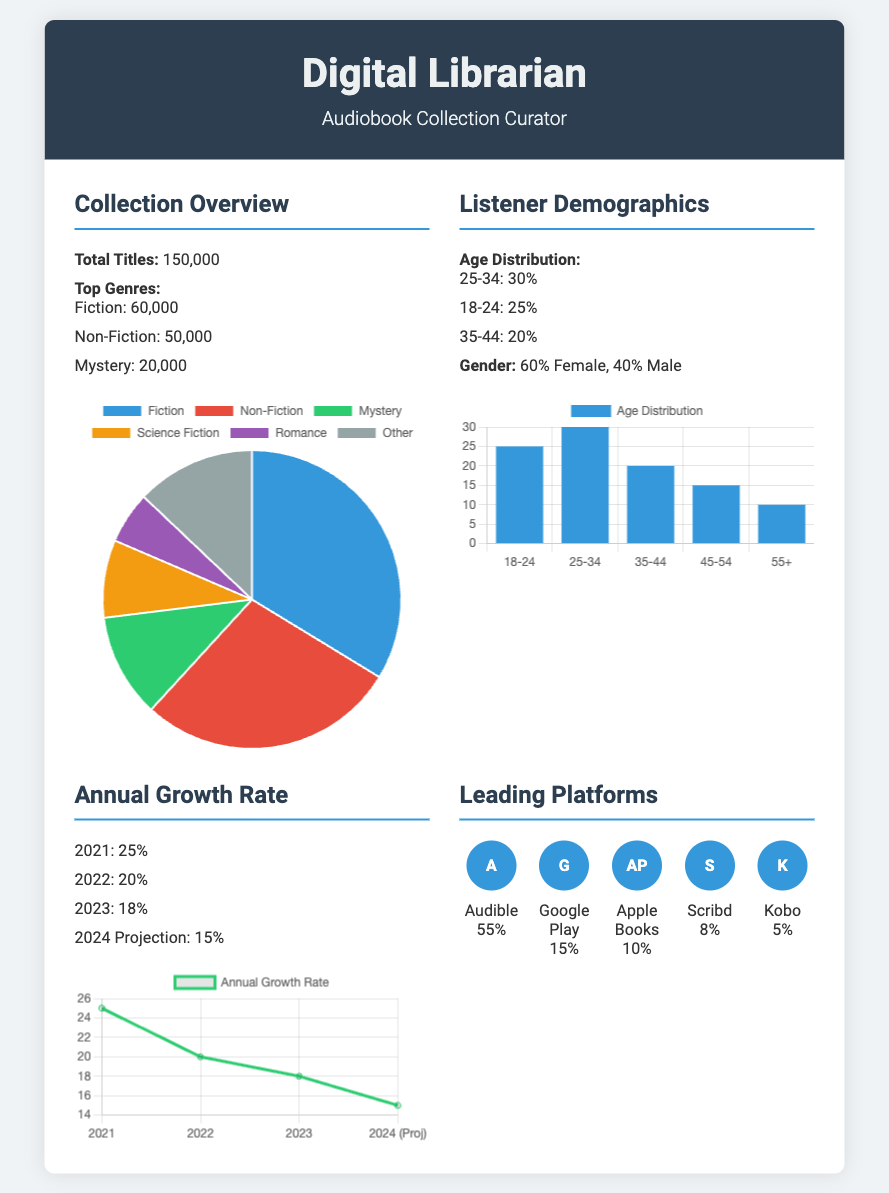what is the total number of audiobook titles? The total number of audiobook titles is stated in the collection overview section, which shows 150,000.
Answer: 150,000 how many titles are in the Fiction genre? The number of titles in the Fiction genre is detailed under the top genres, which lists 60,000 titles.
Answer: 60,000 what percentage of listeners are between the ages of 25-34? The age distribution section shows that 30% of the listeners are between 25-34 years old.
Answer: 30% what is the annual growth rate projection for 2024? The annual growth rate section provides a projection for 2024, which is 15%.
Answer: 15% which platform has the highest percentage of audiobook collection? The leading platforms section indicates that Audible has the highest percentage at 55%.
Answer: Audible how does the growth rate in 2023 compare to 2022? By examining the annual growth rate, we can see that the growth rate is lower in 2023 (18%) compared to 2022 (20%).
Answer: Lower what is the gender distribution of listeners? The listener demographics section specifies that the distribution is 60% Female and 40% Male.
Answer: 60% Female, 40% Male how many titles are there in the Mystery genre? The document lists 20,000 titles under the Mystery genre in the top genres section.
Answer: 20,000 what is the percentage of audiobooks available on Kobo? The leading platforms section shows that Kobo has 5% of the audiobook collection.
Answer: 5% 